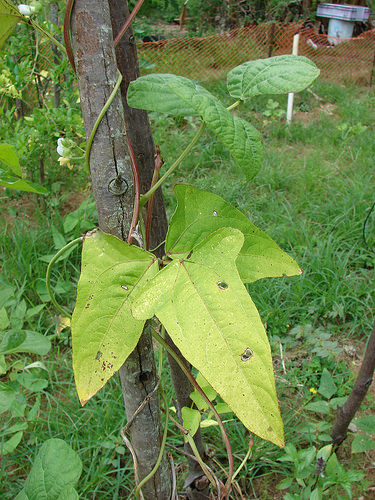<image>
Is the leaf on the stick? Yes. Looking at the image, I can see the leaf is positioned on top of the stick, with the stick providing support. 